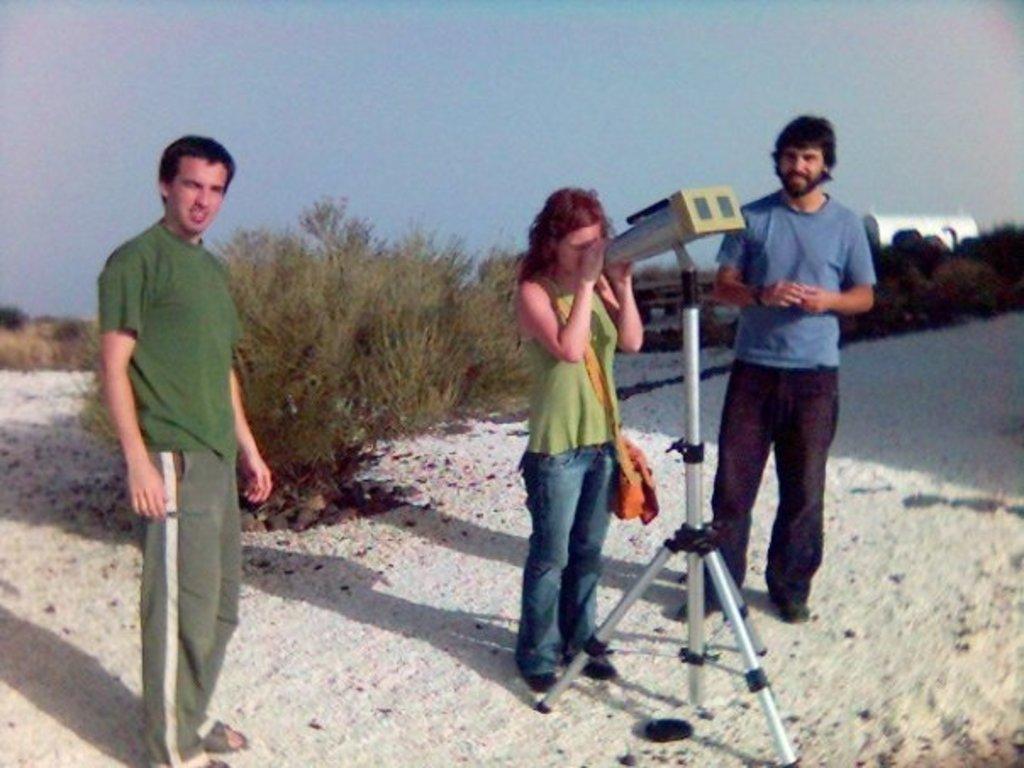How would you summarize this image in a sentence or two? This is an outside view. On the right side there is a binocular tripod. Beside there is a woman standing facing towards the right side, wearing a bag and looking through the binoculars. There are two men standing and looking at the picture. In the background there are many plants and trees. On the right side there is a building. At the top of the image I can see the sky. 